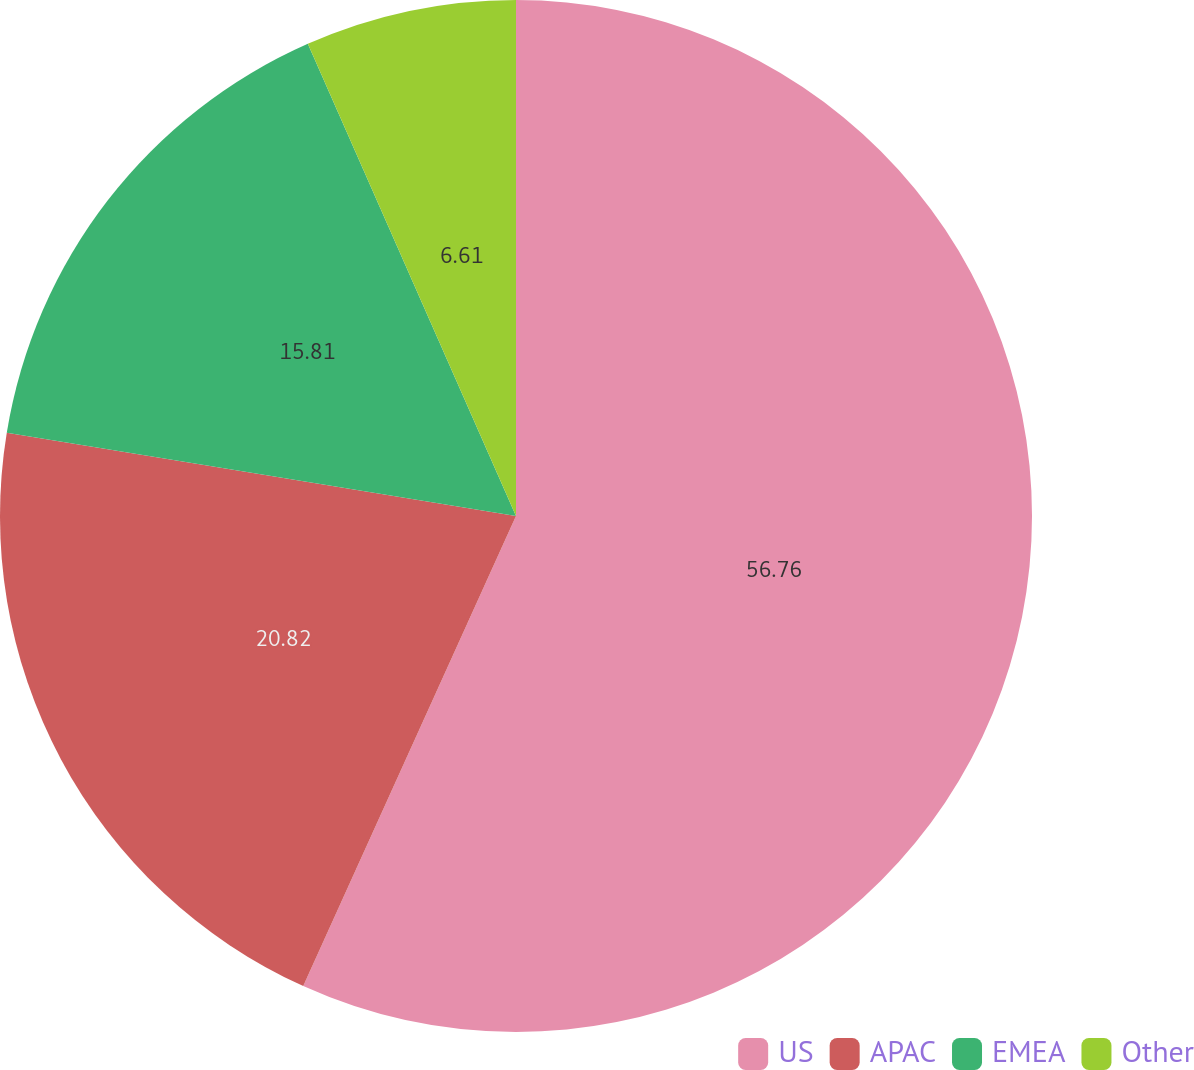Convert chart to OTSL. <chart><loc_0><loc_0><loc_500><loc_500><pie_chart><fcel>US<fcel>APAC<fcel>EMEA<fcel>Other<nl><fcel>56.77%<fcel>20.82%<fcel>15.81%<fcel>6.61%<nl></chart> 